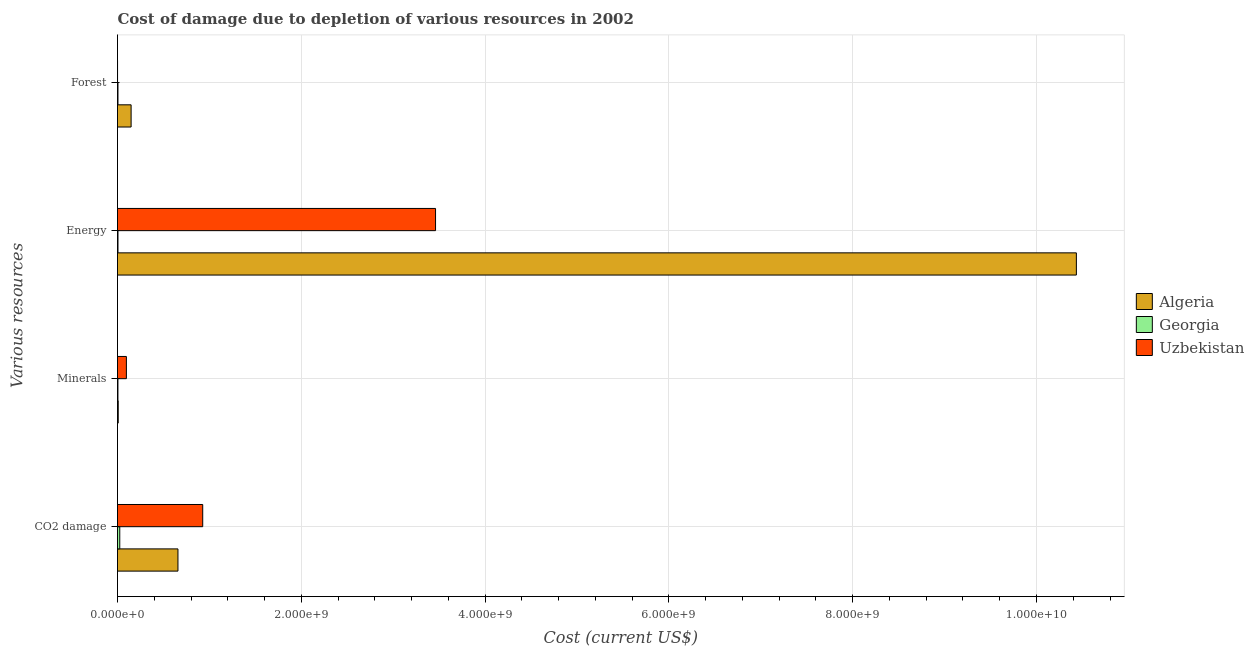Are the number of bars per tick equal to the number of legend labels?
Keep it short and to the point. Yes. How many bars are there on the 3rd tick from the top?
Ensure brevity in your answer.  3. What is the label of the 3rd group of bars from the top?
Your answer should be very brief. Minerals. What is the cost of damage due to depletion of coal in Algeria?
Ensure brevity in your answer.  6.58e+08. Across all countries, what is the maximum cost of damage due to depletion of energy?
Offer a terse response. 1.04e+1. Across all countries, what is the minimum cost of damage due to depletion of energy?
Your answer should be compact. 5.14e+06. In which country was the cost of damage due to depletion of minerals maximum?
Give a very brief answer. Uzbekistan. In which country was the cost of damage due to depletion of coal minimum?
Your answer should be very brief. Georgia. What is the total cost of damage due to depletion of coal in the graph?
Keep it short and to the point. 1.61e+09. What is the difference between the cost of damage due to depletion of forests in Uzbekistan and that in Algeria?
Ensure brevity in your answer.  -1.48e+08. What is the difference between the cost of damage due to depletion of coal in Algeria and the cost of damage due to depletion of energy in Georgia?
Your answer should be very brief. 6.53e+08. What is the average cost of damage due to depletion of energy per country?
Ensure brevity in your answer.  4.63e+09. What is the difference between the cost of damage due to depletion of forests and cost of damage due to depletion of minerals in Algeria?
Offer a terse response. 1.40e+08. What is the ratio of the cost of damage due to depletion of minerals in Georgia to that in Uzbekistan?
Give a very brief answer. 0.05. Is the difference between the cost of damage due to depletion of forests in Uzbekistan and Algeria greater than the difference between the cost of damage due to depletion of energy in Uzbekistan and Algeria?
Offer a terse response. Yes. What is the difference between the highest and the second highest cost of damage due to depletion of coal?
Ensure brevity in your answer.  2.70e+08. What is the difference between the highest and the lowest cost of damage due to depletion of coal?
Provide a short and direct response. 9.03e+08. What does the 1st bar from the top in Energy represents?
Offer a very short reply. Uzbekistan. What does the 1st bar from the bottom in Energy represents?
Make the answer very short. Algeria. Where does the legend appear in the graph?
Provide a short and direct response. Center right. How many legend labels are there?
Your answer should be very brief. 3. What is the title of the graph?
Your answer should be compact. Cost of damage due to depletion of various resources in 2002 . What is the label or title of the X-axis?
Make the answer very short. Cost (current US$). What is the label or title of the Y-axis?
Provide a succinct answer. Various resources. What is the Cost (current US$) of Algeria in CO2 damage?
Provide a short and direct response. 6.58e+08. What is the Cost (current US$) of Georgia in CO2 damage?
Make the answer very short. 2.45e+07. What is the Cost (current US$) in Uzbekistan in CO2 damage?
Your response must be concise. 9.27e+08. What is the Cost (current US$) in Algeria in Minerals?
Your response must be concise. 7.85e+06. What is the Cost (current US$) of Georgia in Minerals?
Provide a succinct answer. 4.67e+06. What is the Cost (current US$) in Uzbekistan in Minerals?
Make the answer very short. 9.67e+07. What is the Cost (current US$) in Algeria in Energy?
Offer a terse response. 1.04e+1. What is the Cost (current US$) of Georgia in Energy?
Provide a short and direct response. 5.14e+06. What is the Cost (current US$) in Uzbekistan in Energy?
Provide a succinct answer. 3.46e+09. What is the Cost (current US$) of Algeria in Forest?
Ensure brevity in your answer.  1.48e+08. What is the Cost (current US$) of Georgia in Forest?
Your response must be concise. 5.06e+06. What is the Cost (current US$) of Uzbekistan in Forest?
Your response must be concise. 3.90e+05. Across all Various resources, what is the maximum Cost (current US$) in Algeria?
Give a very brief answer. 1.04e+1. Across all Various resources, what is the maximum Cost (current US$) in Georgia?
Keep it short and to the point. 2.45e+07. Across all Various resources, what is the maximum Cost (current US$) of Uzbekistan?
Your answer should be compact. 3.46e+09. Across all Various resources, what is the minimum Cost (current US$) in Algeria?
Make the answer very short. 7.85e+06. Across all Various resources, what is the minimum Cost (current US$) in Georgia?
Offer a terse response. 4.67e+06. Across all Various resources, what is the minimum Cost (current US$) of Uzbekistan?
Keep it short and to the point. 3.90e+05. What is the total Cost (current US$) in Algeria in the graph?
Keep it short and to the point. 1.12e+1. What is the total Cost (current US$) of Georgia in the graph?
Ensure brevity in your answer.  3.94e+07. What is the total Cost (current US$) of Uzbekistan in the graph?
Make the answer very short. 4.49e+09. What is the difference between the Cost (current US$) of Algeria in CO2 damage and that in Minerals?
Give a very brief answer. 6.50e+08. What is the difference between the Cost (current US$) in Georgia in CO2 damage and that in Minerals?
Keep it short and to the point. 1.99e+07. What is the difference between the Cost (current US$) in Uzbekistan in CO2 damage and that in Minerals?
Ensure brevity in your answer.  8.31e+08. What is the difference between the Cost (current US$) of Algeria in CO2 damage and that in Energy?
Make the answer very short. -9.78e+09. What is the difference between the Cost (current US$) in Georgia in CO2 damage and that in Energy?
Offer a very short reply. 1.94e+07. What is the difference between the Cost (current US$) of Uzbekistan in CO2 damage and that in Energy?
Provide a short and direct response. -2.53e+09. What is the difference between the Cost (current US$) in Algeria in CO2 damage and that in Forest?
Offer a terse response. 5.10e+08. What is the difference between the Cost (current US$) in Georgia in CO2 damage and that in Forest?
Keep it short and to the point. 1.95e+07. What is the difference between the Cost (current US$) in Uzbekistan in CO2 damage and that in Forest?
Provide a short and direct response. 9.27e+08. What is the difference between the Cost (current US$) of Algeria in Minerals and that in Energy?
Give a very brief answer. -1.04e+1. What is the difference between the Cost (current US$) in Georgia in Minerals and that in Energy?
Keep it short and to the point. -4.69e+05. What is the difference between the Cost (current US$) of Uzbekistan in Minerals and that in Energy?
Offer a very short reply. -3.36e+09. What is the difference between the Cost (current US$) of Algeria in Minerals and that in Forest?
Your answer should be very brief. -1.40e+08. What is the difference between the Cost (current US$) of Georgia in Minerals and that in Forest?
Keep it short and to the point. -3.89e+05. What is the difference between the Cost (current US$) in Uzbekistan in Minerals and that in Forest?
Make the answer very short. 9.63e+07. What is the difference between the Cost (current US$) of Algeria in Energy and that in Forest?
Your answer should be very brief. 1.03e+1. What is the difference between the Cost (current US$) in Georgia in Energy and that in Forest?
Ensure brevity in your answer.  8.05e+04. What is the difference between the Cost (current US$) of Uzbekistan in Energy and that in Forest?
Make the answer very short. 3.46e+09. What is the difference between the Cost (current US$) in Algeria in CO2 damage and the Cost (current US$) in Georgia in Minerals?
Your answer should be very brief. 6.53e+08. What is the difference between the Cost (current US$) of Algeria in CO2 damage and the Cost (current US$) of Uzbekistan in Minerals?
Make the answer very short. 5.61e+08. What is the difference between the Cost (current US$) in Georgia in CO2 damage and the Cost (current US$) in Uzbekistan in Minerals?
Provide a short and direct response. -7.21e+07. What is the difference between the Cost (current US$) in Algeria in CO2 damage and the Cost (current US$) in Georgia in Energy?
Make the answer very short. 6.53e+08. What is the difference between the Cost (current US$) of Algeria in CO2 damage and the Cost (current US$) of Uzbekistan in Energy?
Provide a short and direct response. -2.80e+09. What is the difference between the Cost (current US$) of Georgia in CO2 damage and the Cost (current US$) of Uzbekistan in Energy?
Give a very brief answer. -3.44e+09. What is the difference between the Cost (current US$) in Algeria in CO2 damage and the Cost (current US$) in Georgia in Forest?
Give a very brief answer. 6.53e+08. What is the difference between the Cost (current US$) in Algeria in CO2 damage and the Cost (current US$) in Uzbekistan in Forest?
Offer a terse response. 6.57e+08. What is the difference between the Cost (current US$) in Georgia in CO2 damage and the Cost (current US$) in Uzbekistan in Forest?
Make the answer very short. 2.41e+07. What is the difference between the Cost (current US$) of Algeria in Minerals and the Cost (current US$) of Georgia in Energy?
Ensure brevity in your answer.  2.72e+06. What is the difference between the Cost (current US$) of Algeria in Minerals and the Cost (current US$) of Uzbekistan in Energy?
Your response must be concise. -3.45e+09. What is the difference between the Cost (current US$) of Georgia in Minerals and the Cost (current US$) of Uzbekistan in Energy?
Your answer should be very brief. -3.46e+09. What is the difference between the Cost (current US$) in Algeria in Minerals and the Cost (current US$) in Georgia in Forest?
Make the answer very short. 2.80e+06. What is the difference between the Cost (current US$) in Algeria in Minerals and the Cost (current US$) in Uzbekistan in Forest?
Keep it short and to the point. 7.46e+06. What is the difference between the Cost (current US$) of Georgia in Minerals and the Cost (current US$) of Uzbekistan in Forest?
Offer a very short reply. 4.28e+06. What is the difference between the Cost (current US$) of Algeria in Energy and the Cost (current US$) of Georgia in Forest?
Offer a very short reply. 1.04e+1. What is the difference between the Cost (current US$) in Algeria in Energy and the Cost (current US$) in Uzbekistan in Forest?
Your answer should be very brief. 1.04e+1. What is the difference between the Cost (current US$) of Georgia in Energy and the Cost (current US$) of Uzbekistan in Forest?
Make the answer very short. 4.75e+06. What is the average Cost (current US$) of Algeria per Various resources?
Provide a short and direct response. 2.81e+09. What is the average Cost (current US$) of Georgia per Various resources?
Your answer should be very brief. 9.85e+06. What is the average Cost (current US$) of Uzbekistan per Various resources?
Give a very brief answer. 1.12e+09. What is the difference between the Cost (current US$) of Algeria and Cost (current US$) of Georgia in CO2 damage?
Your response must be concise. 6.33e+08. What is the difference between the Cost (current US$) in Algeria and Cost (current US$) in Uzbekistan in CO2 damage?
Your answer should be very brief. -2.70e+08. What is the difference between the Cost (current US$) in Georgia and Cost (current US$) in Uzbekistan in CO2 damage?
Provide a short and direct response. -9.03e+08. What is the difference between the Cost (current US$) of Algeria and Cost (current US$) of Georgia in Minerals?
Give a very brief answer. 3.19e+06. What is the difference between the Cost (current US$) in Algeria and Cost (current US$) in Uzbekistan in Minerals?
Your answer should be compact. -8.88e+07. What is the difference between the Cost (current US$) of Georgia and Cost (current US$) of Uzbekistan in Minerals?
Offer a terse response. -9.20e+07. What is the difference between the Cost (current US$) of Algeria and Cost (current US$) of Georgia in Energy?
Give a very brief answer. 1.04e+1. What is the difference between the Cost (current US$) in Algeria and Cost (current US$) in Uzbekistan in Energy?
Provide a short and direct response. 6.97e+09. What is the difference between the Cost (current US$) of Georgia and Cost (current US$) of Uzbekistan in Energy?
Keep it short and to the point. -3.46e+09. What is the difference between the Cost (current US$) in Algeria and Cost (current US$) in Georgia in Forest?
Your answer should be compact. 1.43e+08. What is the difference between the Cost (current US$) in Algeria and Cost (current US$) in Uzbekistan in Forest?
Your response must be concise. 1.48e+08. What is the difference between the Cost (current US$) of Georgia and Cost (current US$) of Uzbekistan in Forest?
Provide a succinct answer. 4.67e+06. What is the ratio of the Cost (current US$) of Algeria in CO2 damage to that in Minerals?
Provide a short and direct response. 83.75. What is the ratio of the Cost (current US$) in Georgia in CO2 damage to that in Minerals?
Keep it short and to the point. 5.26. What is the ratio of the Cost (current US$) of Uzbekistan in CO2 damage to that in Minerals?
Give a very brief answer. 9.59. What is the ratio of the Cost (current US$) of Algeria in CO2 damage to that in Energy?
Your answer should be compact. 0.06. What is the ratio of the Cost (current US$) in Georgia in CO2 damage to that in Energy?
Offer a very short reply. 4.78. What is the ratio of the Cost (current US$) of Uzbekistan in CO2 damage to that in Energy?
Make the answer very short. 0.27. What is the ratio of the Cost (current US$) of Algeria in CO2 damage to that in Forest?
Ensure brevity in your answer.  4.44. What is the ratio of the Cost (current US$) in Georgia in CO2 damage to that in Forest?
Your answer should be very brief. 4.85. What is the ratio of the Cost (current US$) of Uzbekistan in CO2 damage to that in Forest?
Offer a very short reply. 2377.4. What is the ratio of the Cost (current US$) of Algeria in Minerals to that in Energy?
Provide a succinct answer. 0. What is the ratio of the Cost (current US$) of Georgia in Minerals to that in Energy?
Make the answer very short. 0.91. What is the ratio of the Cost (current US$) in Uzbekistan in Minerals to that in Energy?
Ensure brevity in your answer.  0.03. What is the ratio of the Cost (current US$) in Algeria in Minerals to that in Forest?
Make the answer very short. 0.05. What is the ratio of the Cost (current US$) in Georgia in Minerals to that in Forest?
Make the answer very short. 0.92. What is the ratio of the Cost (current US$) in Uzbekistan in Minerals to that in Forest?
Keep it short and to the point. 247.81. What is the ratio of the Cost (current US$) in Algeria in Energy to that in Forest?
Give a very brief answer. 70.49. What is the ratio of the Cost (current US$) of Georgia in Energy to that in Forest?
Make the answer very short. 1.02. What is the ratio of the Cost (current US$) of Uzbekistan in Energy to that in Forest?
Offer a terse response. 8872.74. What is the difference between the highest and the second highest Cost (current US$) in Algeria?
Provide a succinct answer. 9.78e+09. What is the difference between the highest and the second highest Cost (current US$) of Georgia?
Offer a very short reply. 1.94e+07. What is the difference between the highest and the second highest Cost (current US$) in Uzbekistan?
Keep it short and to the point. 2.53e+09. What is the difference between the highest and the lowest Cost (current US$) of Algeria?
Provide a short and direct response. 1.04e+1. What is the difference between the highest and the lowest Cost (current US$) in Georgia?
Your answer should be very brief. 1.99e+07. What is the difference between the highest and the lowest Cost (current US$) in Uzbekistan?
Offer a terse response. 3.46e+09. 